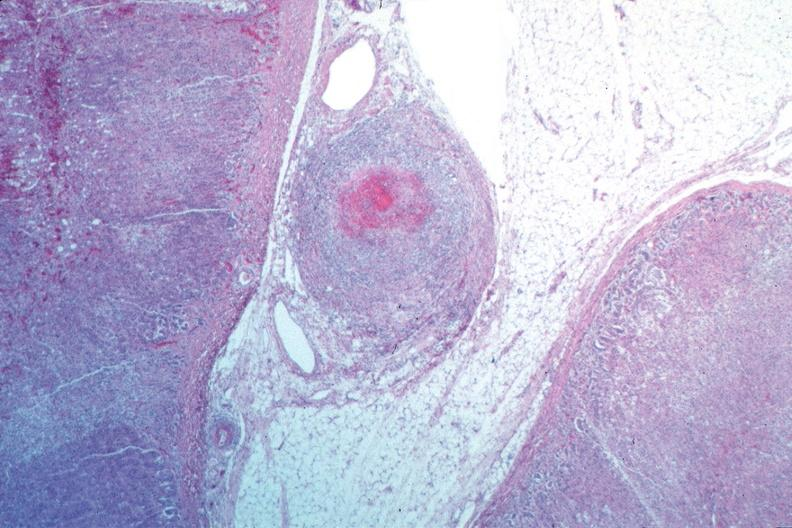what does this image show?
Answer the question using a single word or phrase. Vasculitis 